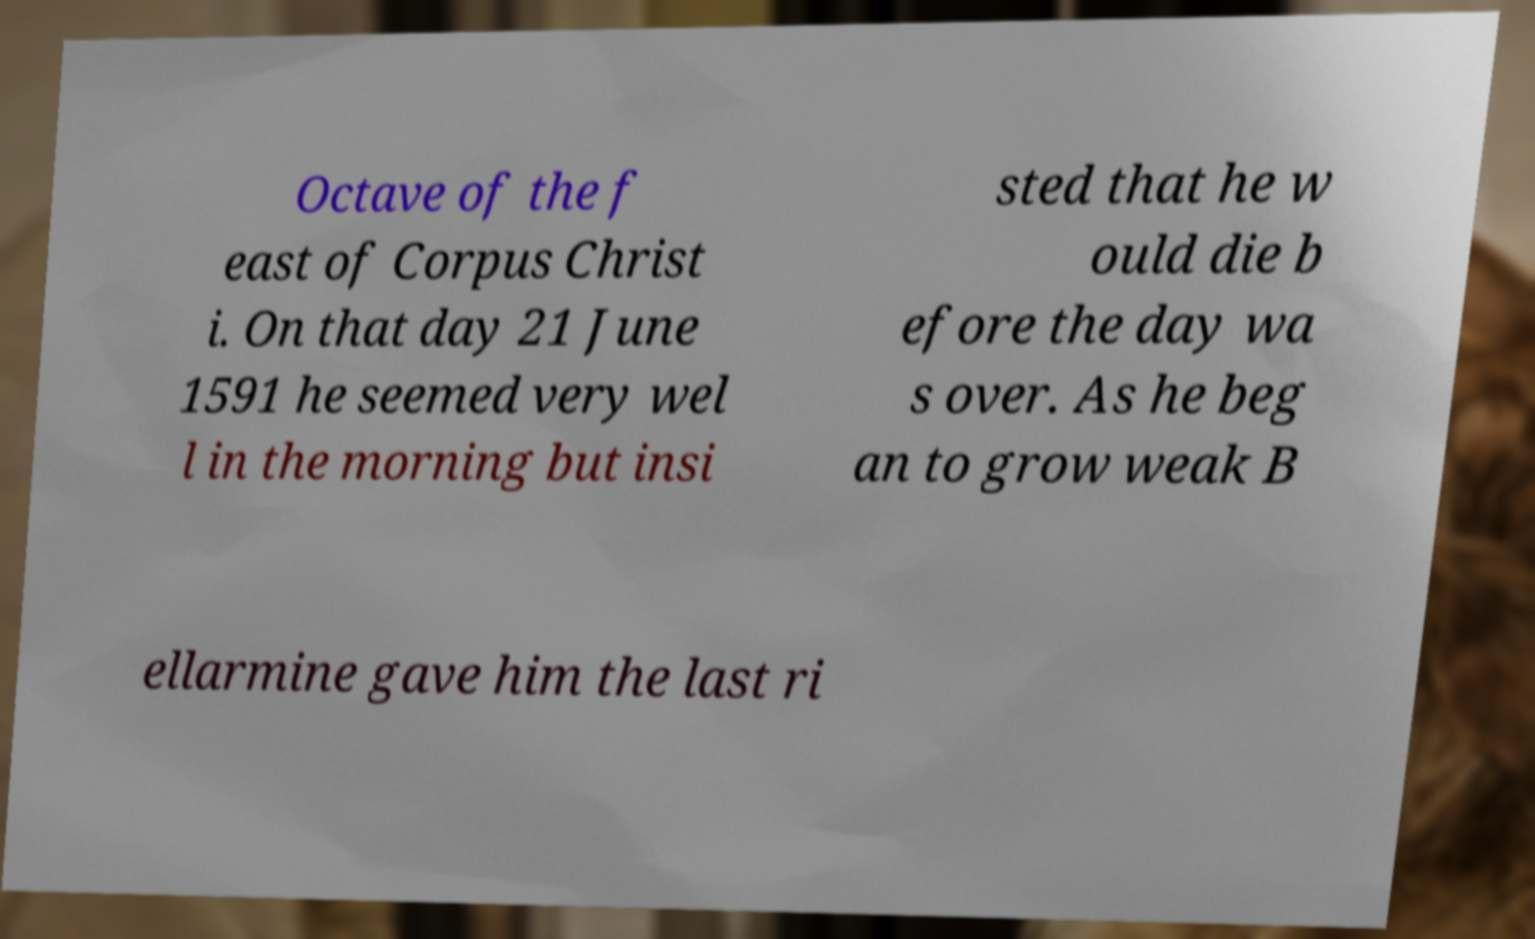Please identify and transcribe the text found in this image. Octave of the f east of Corpus Christ i. On that day 21 June 1591 he seemed very wel l in the morning but insi sted that he w ould die b efore the day wa s over. As he beg an to grow weak B ellarmine gave him the last ri 